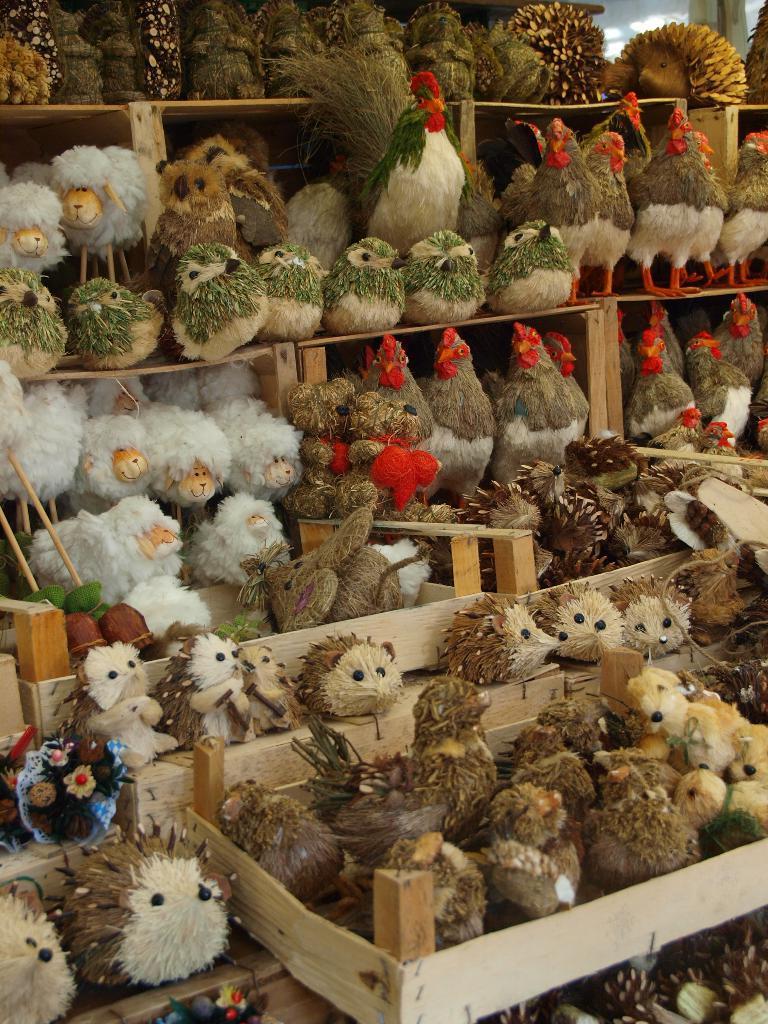How would you summarize this image in a sentence or two? In this image we can see toys placed in the rack. 